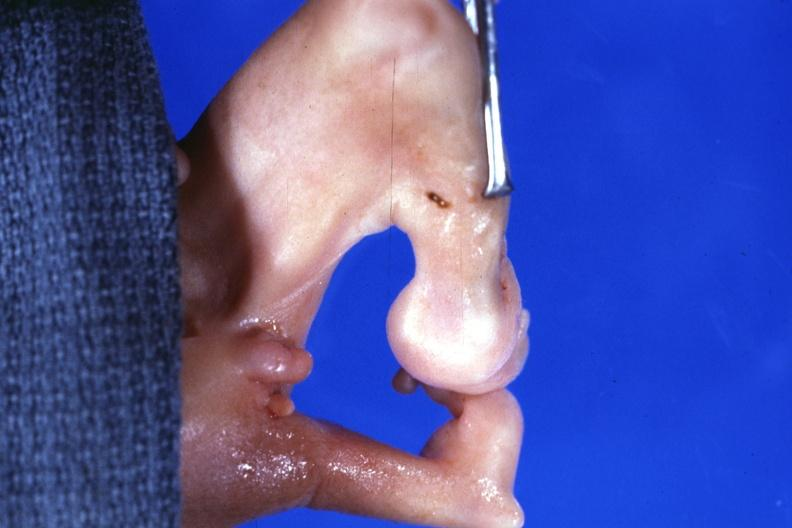what are present?
Answer the question using a single word or phrase. Extremities 